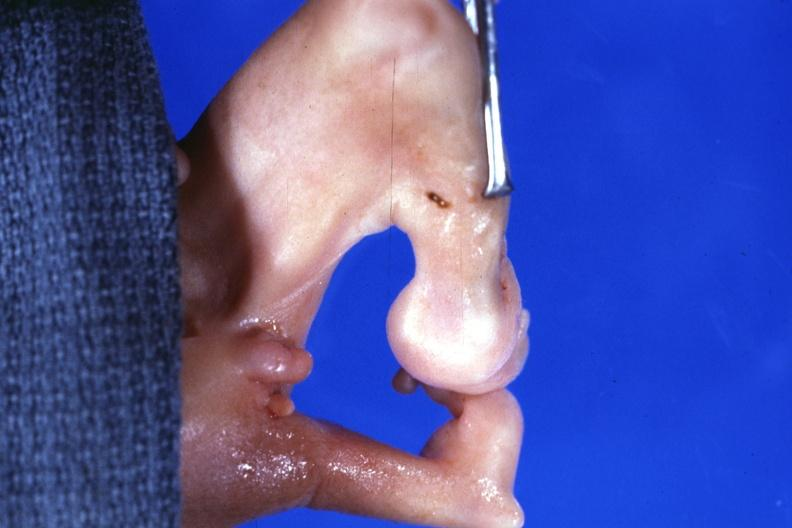what are present?
Answer the question using a single word or phrase. Extremities 